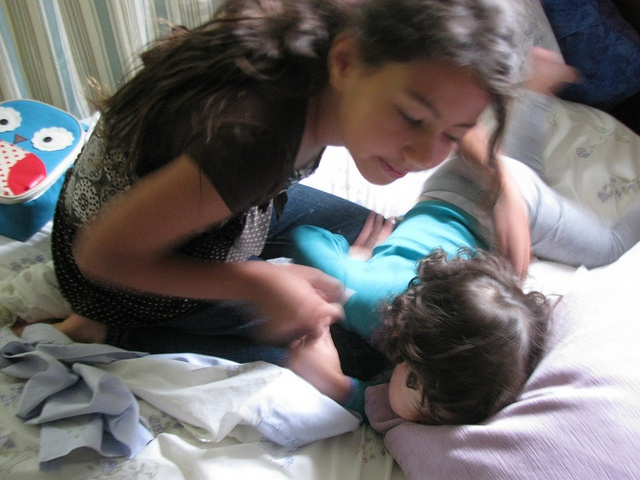Describe the objects in this image and their specific colors. I can see bed in black, gray, white, and darkgray tones, people in gray, black, and maroon tones, people in gray, black, lightgray, and darkgray tones, and backpack in gray, lightgray, lightblue, black, and red tones in this image. 